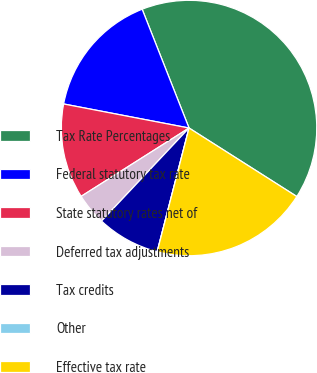Convert chart to OTSL. <chart><loc_0><loc_0><loc_500><loc_500><pie_chart><fcel>Tax Rate Percentages<fcel>Federal statutory tax rate<fcel>State statutory rates net of<fcel>Deferred tax adjustments<fcel>Tax credits<fcel>Other<fcel>Effective tax rate<nl><fcel>39.99%<fcel>16.0%<fcel>12.0%<fcel>4.0%<fcel>8.0%<fcel>0.0%<fcel>20.0%<nl></chart> 